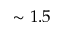<formula> <loc_0><loc_0><loc_500><loc_500>\sim 1 . 5</formula> 